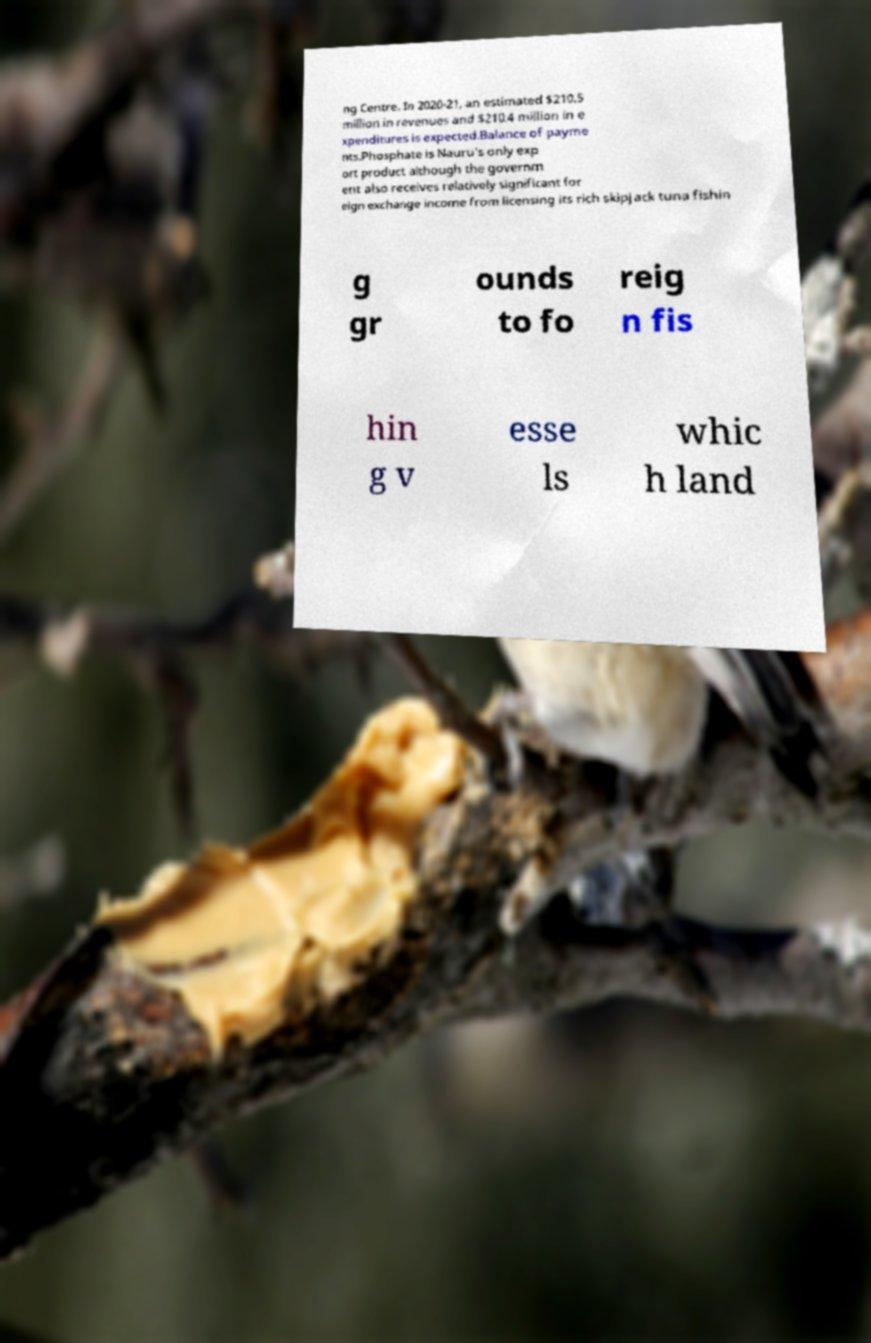For documentation purposes, I need the text within this image transcribed. Could you provide that? ng Centre. In 2020-21, an estimated $210.5 million in revenues and $210.4 million in e xpenditures is expected.Balance of payme nts.Phosphate is Nauru's only exp ort product although the governm ent also receives relatively significant for eign exchange income from licensing its rich skipjack tuna fishin g gr ounds to fo reig n fis hin g v esse ls whic h land 